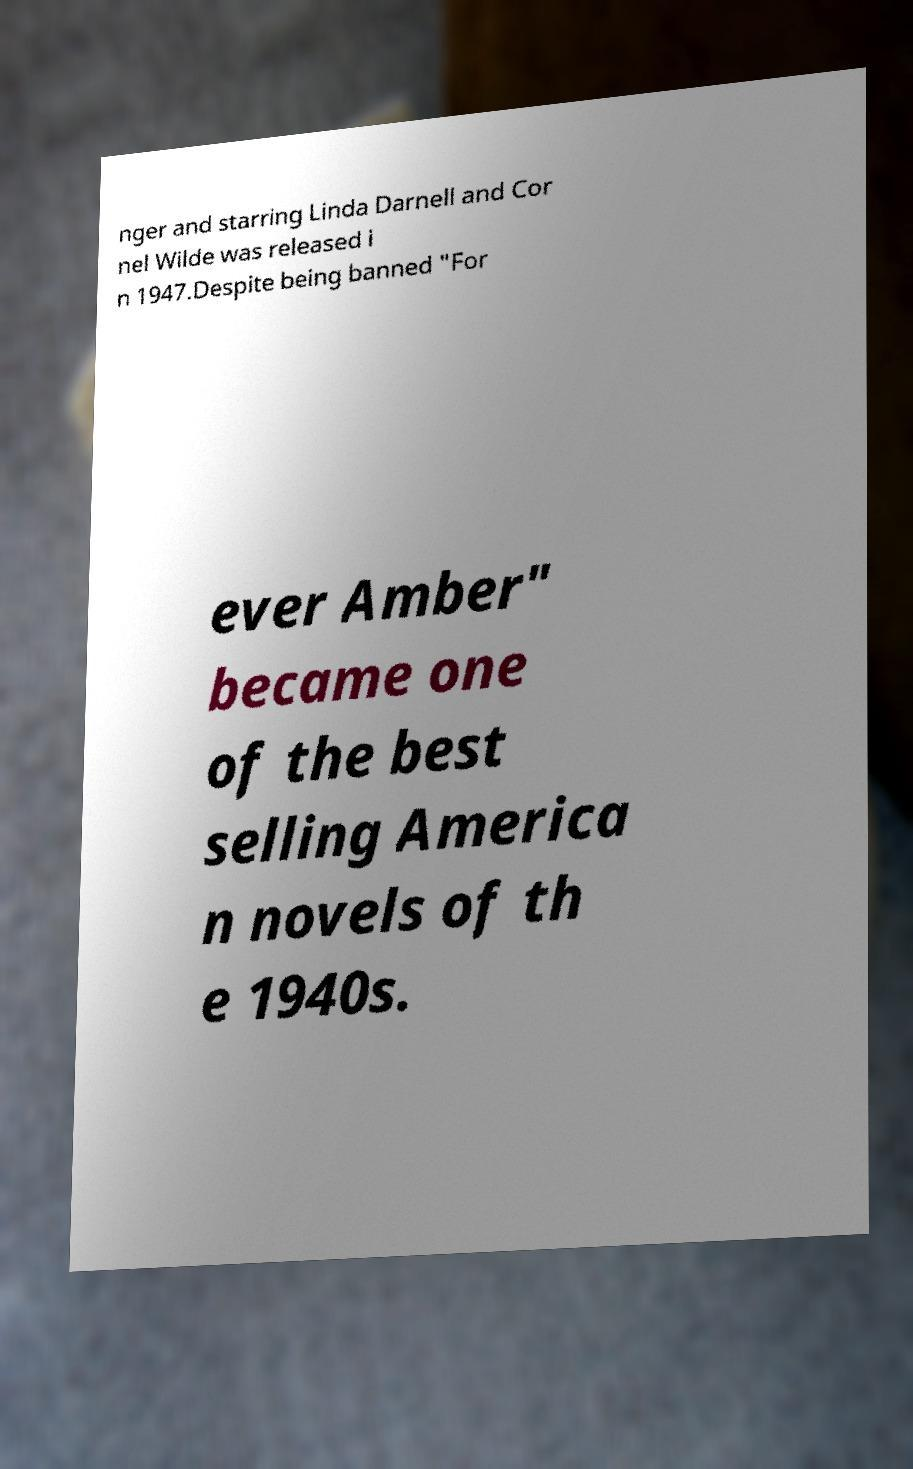I need the written content from this picture converted into text. Can you do that? nger and starring Linda Darnell and Cor nel Wilde was released i n 1947.Despite being banned "For ever Amber" became one of the best selling America n novels of th e 1940s. 